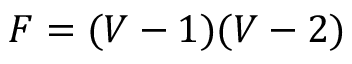<formula> <loc_0><loc_0><loc_500><loc_500>F = ( V - 1 ) ( V - 2 )</formula> 